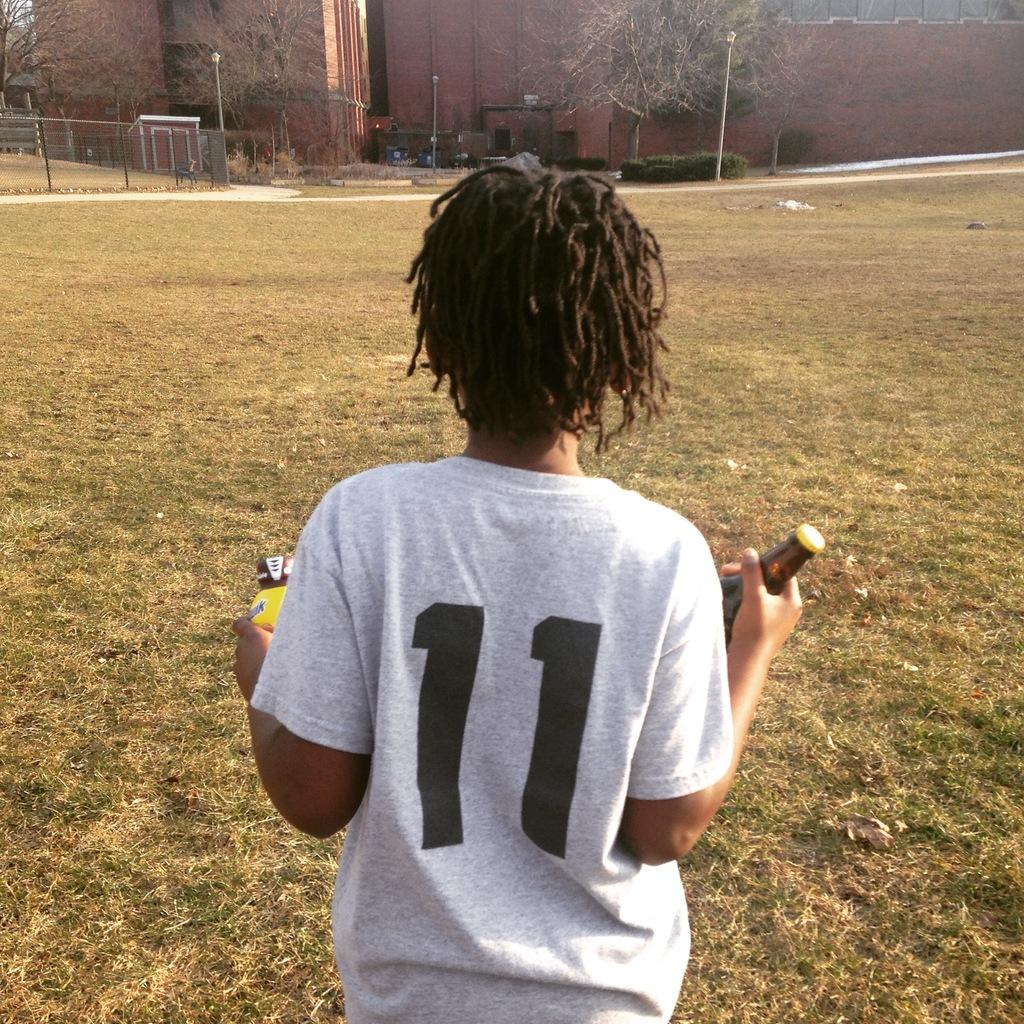Who is present in the image? There is a boy in the image. What is the boy holding in his hand? The boy is holding a bottle in his hand. What structures can be seen in the image? There are poles, a fence, trees, and buildings in the image. What type of instrument is the boy playing in the image? There is no instrument present in the image, and the boy is not playing any instrument. 